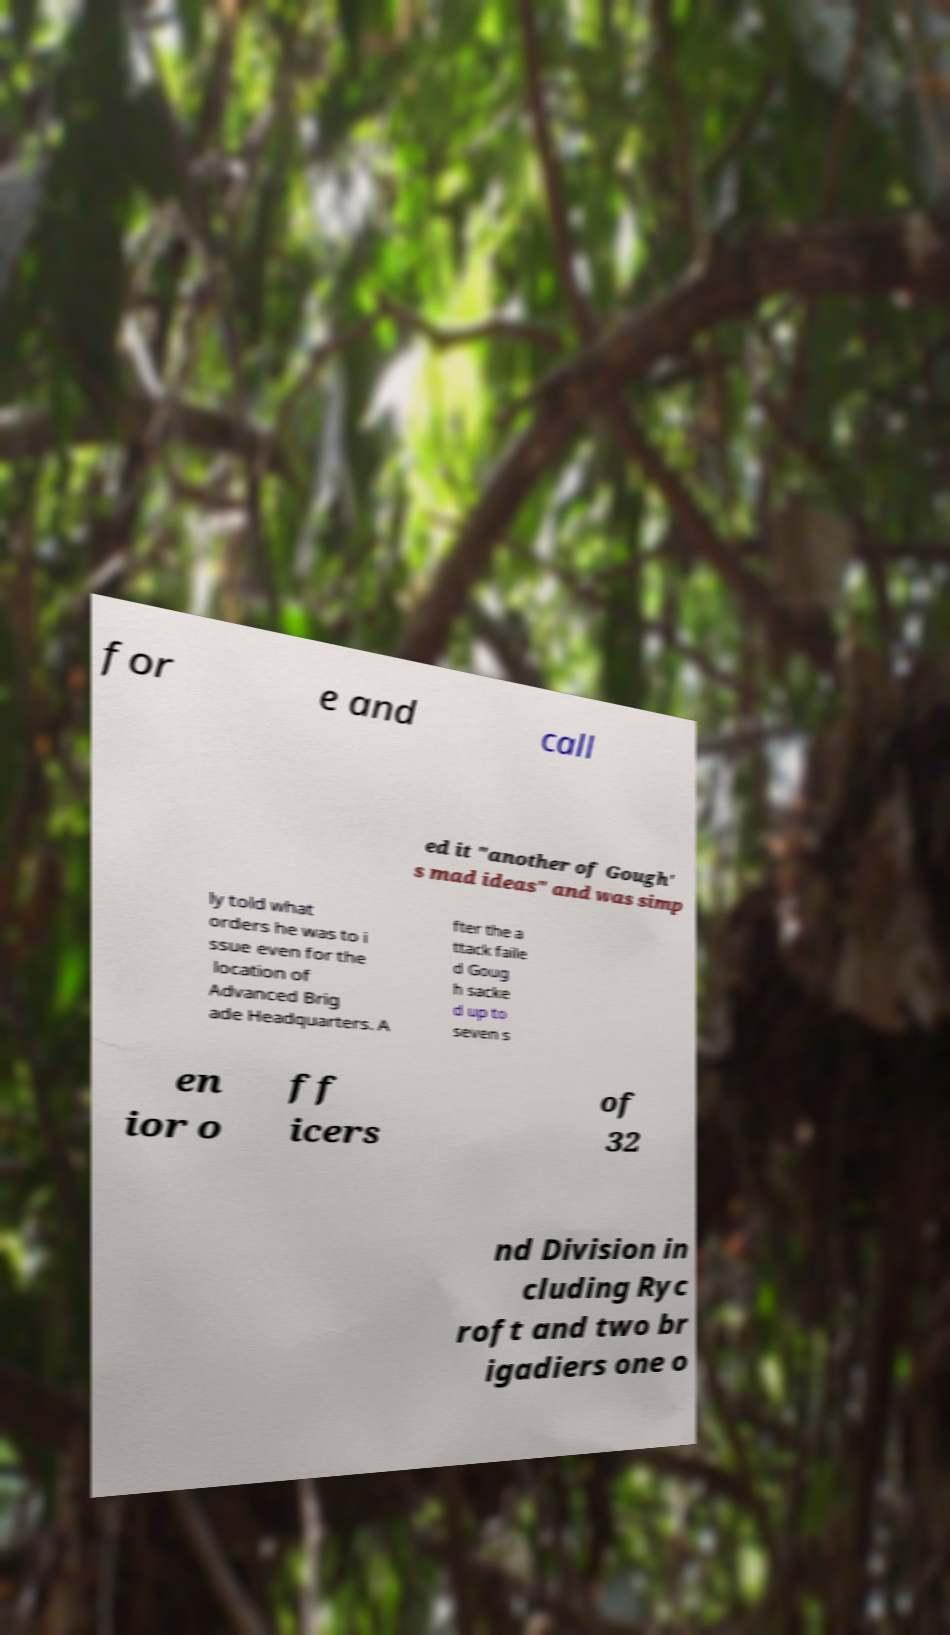There's text embedded in this image that I need extracted. Can you transcribe it verbatim? for e and call ed it "another of Gough' s mad ideas" and was simp ly told what orders he was to i ssue even for the location of Advanced Brig ade Headquarters. A fter the a ttack faile d Goug h sacke d up to seven s en ior o ff icers of 32 nd Division in cluding Ryc roft and two br igadiers one o 